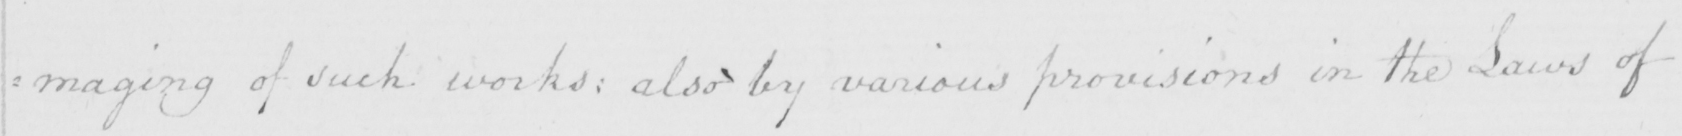Please transcribe the handwritten text in this image. : maging of such works :  also by various provisions in the Laws of 